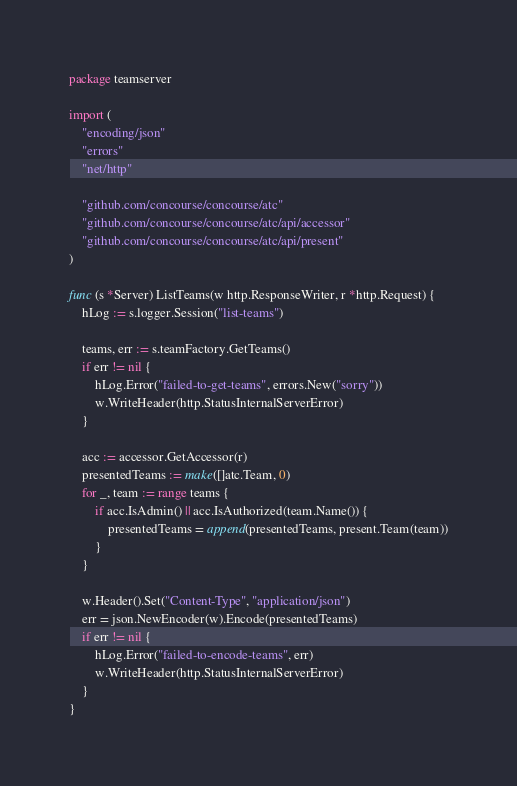<code> <loc_0><loc_0><loc_500><loc_500><_Go_>package teamserver

import (
	"encoding/json"
	"errors"
	"net/http"

	"github.com/concourse/concourse/atc"
	"github.com/concourse/concourse/atc/api/accessor"
	"github.com/concourse/concourse/atc/api/present"
)

func (s *Server) ListTeams(w http.ResponseWriter, r *http.Request) {
	hLog := s.logger.Session("list-teams")

	teams, err := s.teamFactory.GetTeams()
	if err != nil {
		hLog.Error("failed-to-get-teams", errors.New("sorry"))
		w.WriteHeader(http.StatusInternalServerError)
	}

	acc := accessor.GetAccessor(r)
	presentedTeams := make([]atc.Team, 0)
	for _, team := range teams {
		if acc.IsAdmin() || acc.IsAuthorized(team.Name()) {
			presentedTeams = append(presentedTeams, present.Team(team))
		}
	}

	w.Header().Set("Content-Type", "application/json")
	err = json.NewEncoder(w).Encode(presentedTeams)
	if err != nil {
		hLog.Error("failed-to-encode-teams", err)
		w.WriteHeader(http.StatusInternalServerError)
	}
}
</code> 